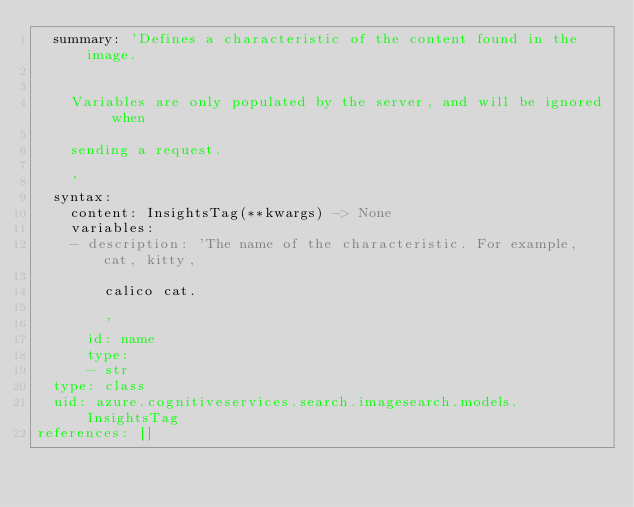Convert code to text. <code><loc_0><loc_0><loc_500><loc_500><_YAML_>  summary: 'Defines a characteristic of the content found in the image.


    Variables are only populated by the server, and will be ignored when

    sending a request.

    '
  syntax:
    content: InsightsTag(**kwargs) -> None
    variables:
    - description: 'The name of the characteristic. For example, cat, kitty,

        calico cat.

        '
      id: name
      type:
      - str
  type: class
  uid: azure.cognitiveservices.search.imagesearch.models.InsightsTag
references: []
</code> 